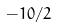Convert formula to latex. <formula><loc_0><loc_0><loc_500><loc_500>- 1 0 / 2</formula> 